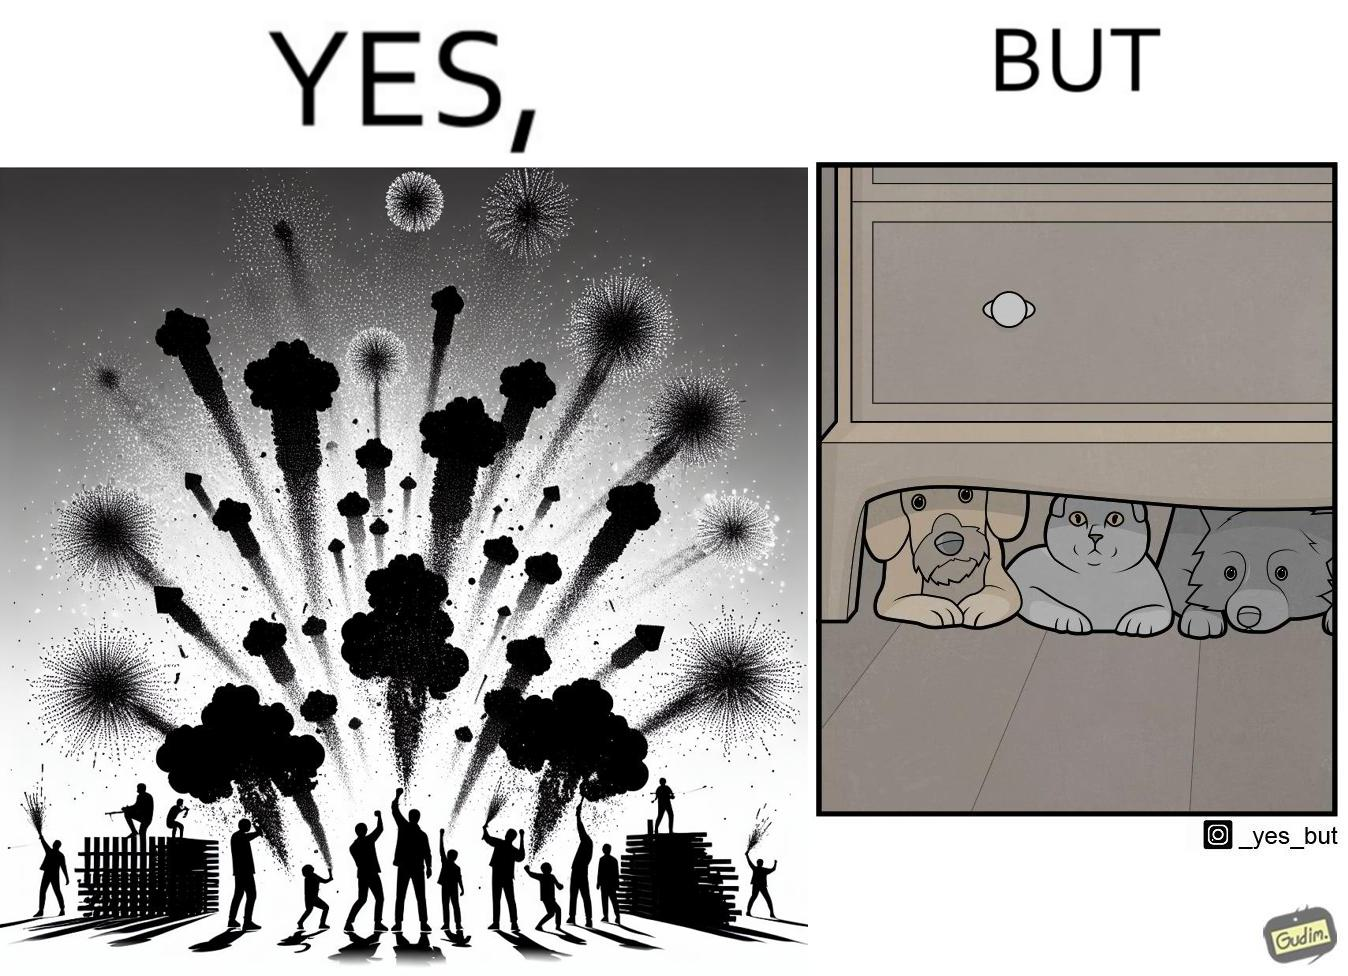Would you classify this image as satirical? Yes, this image is satirical. 